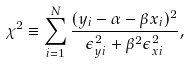Convert formula to latex. <formula><loc_0><loc_0><loc_500><loc_500>\chi ^ { 2 } \equiv \sum ^ { N } _ { i = 1 } \frac { ( y _ { i } - \alpha - \beta x _ { i } ) ^ { 2 } } { \epsilon ^ { 2 } _ { y i } + \beta ^ { 2 } \epsilon ^ { 2 } _ { x i } } ,</formula> 